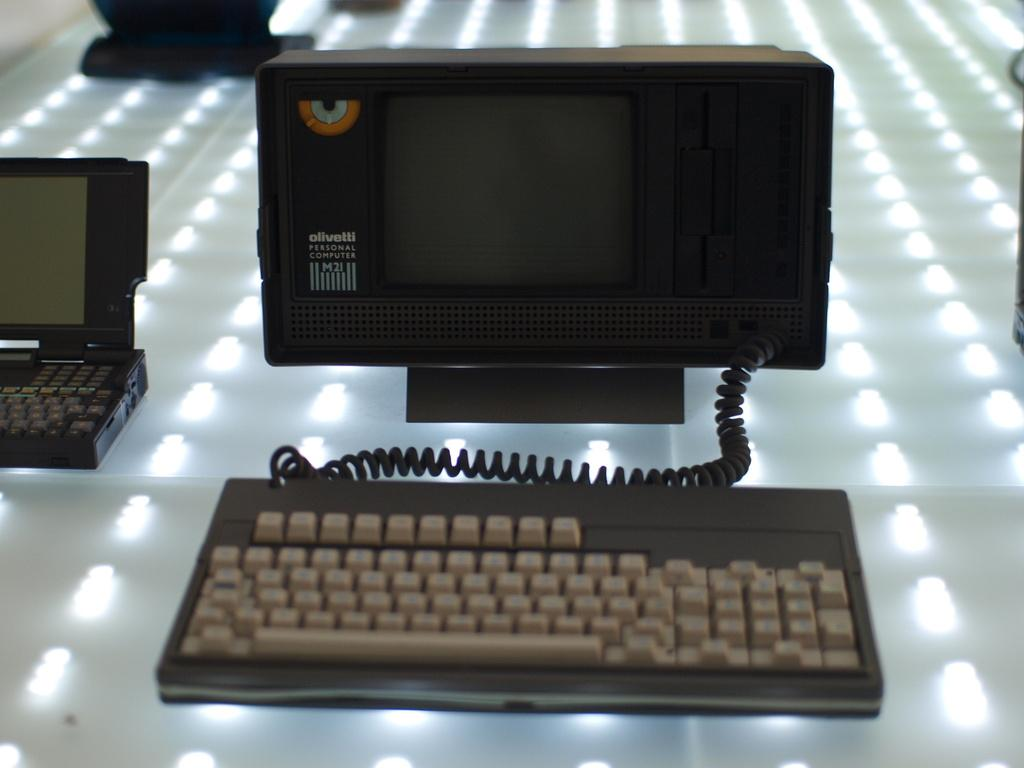<image>
Offer a succinct explanation of the picture presented. An Olivetti Personal Computer M2I small personal computer 